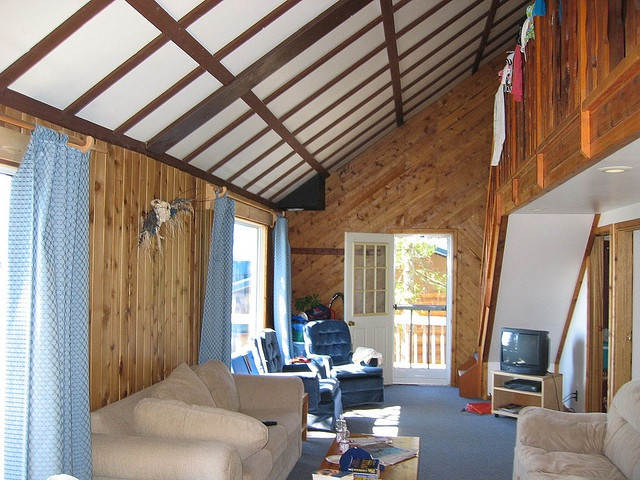Describe the objects in this image and their specific colors. I can see couch in lightgray, gray, and darkgray tones, couch in lightgray, darkgray, and gray tones, chair in lightgray, navy, darkblue, white, and black tones, tv in lightgray, blue, black, and gray tones, and chair in lightgray, gray, white, blue, and navy tones in this image. 